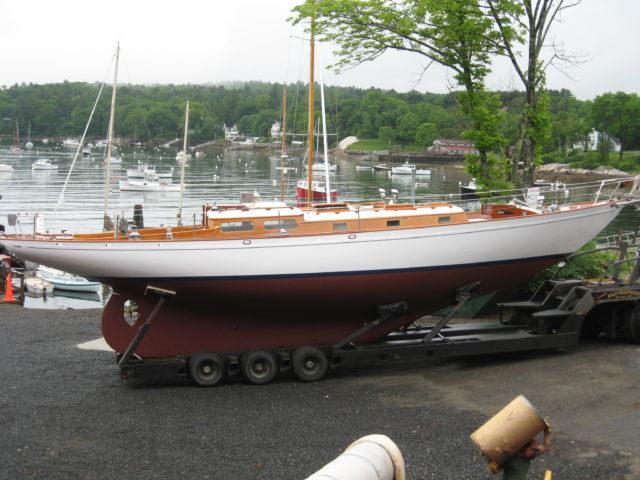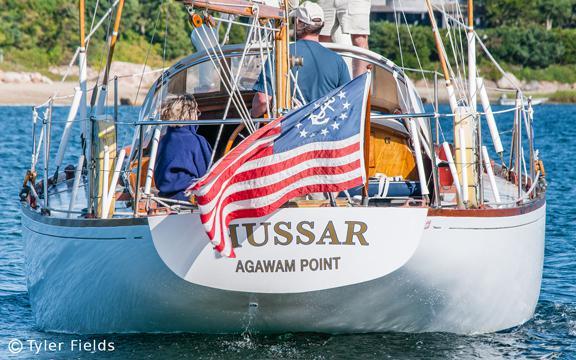The first image is the image on the left, the second image is the image on the right. For the images shown, is this caption "The left and right image contains a total of two sailboats in the water." true? Answer yes or no. No. The first image is the image on the left, the second image is the image on the right. Given the left and right images, does the statement "A boat is tied up to a dock." hold true? Answer yes or no. No. 